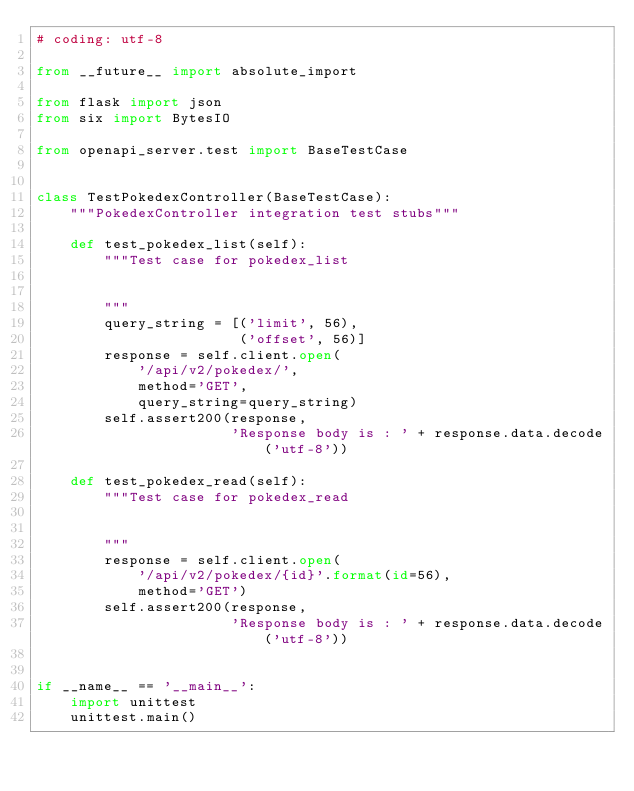Convert code to text. <code><loc_0><loc_0><loc_500><loc_500><_Python_># coding: utf-8

from __future__ import absolute_import

from flask import json
from six import BytesIO

from openapi_server.test import BaseTestCase


class TestPokedexController(BaseTestCase):
    """PokedexController integration test stubs"""

    def test_pokedex_list(self):
        """Test case for pokedex_list

        
        """
        query_string = [('limit', 56),
                        ('offset', 56)]
        response = self.client.open(
            '/api/v2/pokedex/',
            method='GET',
            query_string=query_string)
        self.assert200(response,
                       'Response body is : ' + response.data.decode('utf-8'))

    def test_pokedex_read(self):
        """Test case for pokedex_read

        
        """
        response = self.client.open(
            '/api/v2/pokedex/{id}'.format(id=56),
            method='GET')
        self.assert200(response,
                       'Response body is : ' + response.data.decode('utf-8'))


if __name__ == '__main__':
    import unittest
    unittest.main()
</code> 